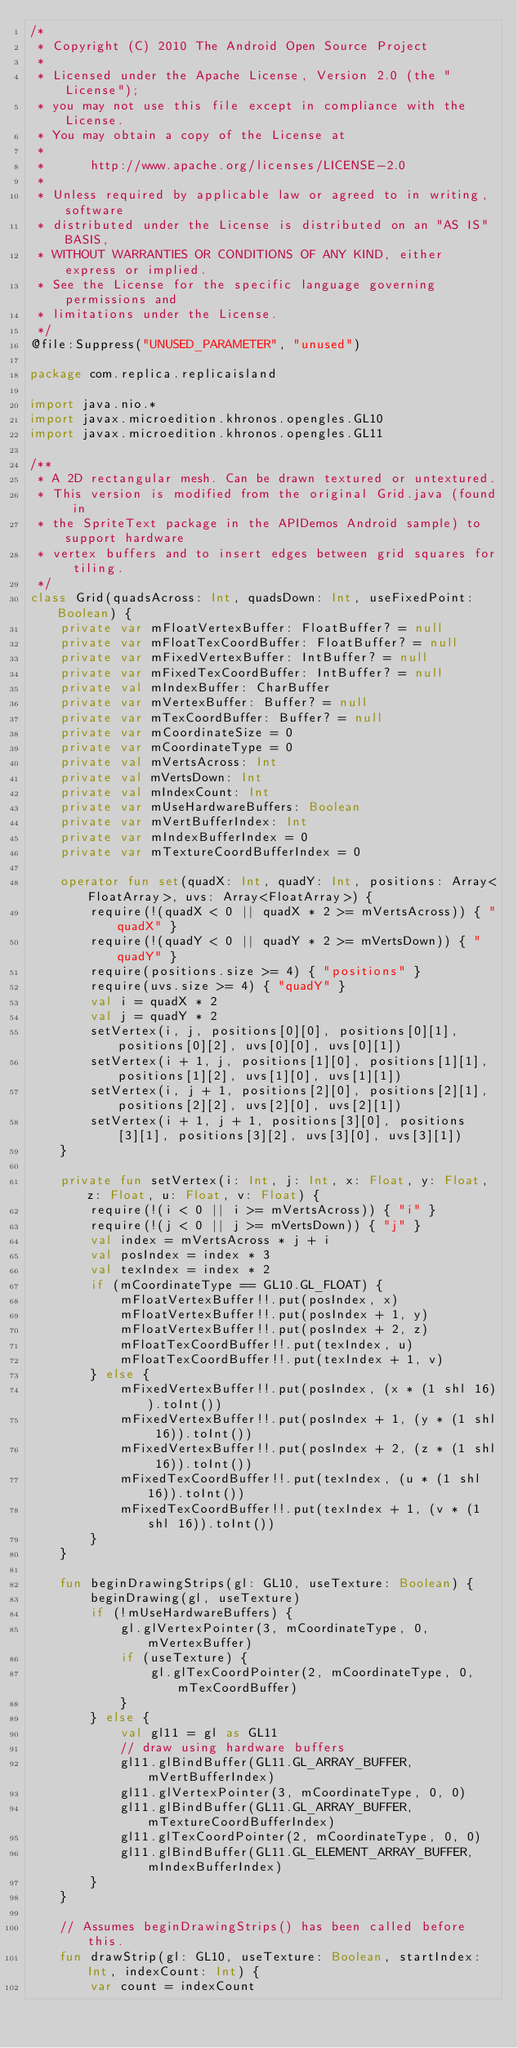<code> <loc_0><loc_0><loc_500><loc_500><_Kotlin_>/*
 * Copyright (C) 2010 The Android Open Source Project
 *
 * Licensed under the Apache License, Version 2.0 (the "License");
 * you may not use this file except in compliance with the License.
 * You may obtain a copy of the License at
 *
 *      http://www.apache.org/licenses/LICENSE-2.0
 *
 * Unless required by applicable law or agreed to in writing, software
 * distributed under the License is distributed on an "AS IS" BASIS,
 * WITHOUT WARRANTIES OR CONDITIONS OF ANY KIND, either express or implied.
 * See the License for the specific language governing permissions and
 * limitations under the License.
 */
@file:Suppress("UNUSED_PARAMETER", "unused")

package com.replica.replicaisland

import java.nio.*
import javax.microedition.khronos.opengles.GL10
import javax.microedition.khronos.opengles.GL11

/**
 * A 2D rectangular mesh. Can be drawn textured or untextured.
 * This version is modified from the original Grid.java (found in
 * the SpriteText package in the APIDemos Android sample) to support hardware
 * vertex buffers and to insert edges between grid squares for tiling.
 */
class Grid(quadsAcross: Int, quadsDown: Int, useFixedPoint: Boolean) {
    private var mFloatVertexBuffer: FloatBuffer? = null
    private var mFloatTexCoordBuffer: FloatBuffer? = null
    private var mFixedVertexBuffer: IntBuffer? = null
    private var mFixedTexCoordBuffer: IntBuffer? = null
    private val mIndexBuffer: CharBuffer
    private var mVertexBuffer: Buffer? = null
    private var mTexCoordBuffer: Buffer? = null
    private var mCoordinateSize = 0
    private var mCoordinateType = 0
    private val mVertsAcross: Int
    private val mVertsDown: Int
    private val mIndexCount: Int
    private var mUseHardwareBuffers: Boolean
    private var mVertBufferIndex: Int
    private var mIndexBufferIndex = 0
    private var mTextureCoordBufferIndex = 0

    operator fun set(quadX: Int, quadY: Int, positions: Array<FloatArray>, uvs: Array<FloatArray>) {
        require(!(quadX < 0 || quadX * 2 >= mVertsAcross)) { "quadX" }
        require(!(quadY < 0 || quadY * 2 >= mVertsDown)) { "quadY" }
        require(positions.size >= 4) { "positions" }
        require(uvs.size >= 4) { "quadY" }
        val i = quadX * 2
        val j = quadY * 2
        setVertex(i, j, positions[0][0], positions[0][1], positions[0][2], uvs[0][0], uvs[0][1])
        setVertex(i + 1, j, positions[1][0], positions[1][1], positions[1][2], uvs[1][0], uvs[1][1])
        setVertex(i, j + 1, positions[2][0], positions[2][1], positions[2][2], uvs[2][0], uvs[2][1])
        setVertex(i + 1, j + 1, positions[3][0], positions[3][1], positions[3][2], uvs[3][0], uvs[3][1])
    }

    private fun setVertex(i: Int, j: Int, x: Float, y: Float, z: Float, u: Float, v: Float) {
        require(!(i < 0 || i >= mVertsAcross)) { "i" }
        require(!(j < 0 || j >= mVertsDown)) { "j" }
        val index = mVertsAcross * j + i
        val posIndex = index * 3
        val texIndex = index * 2
        if (mCoordinateType == GL10.GL_FLOAT) {
            mFloatVertexBuffer!!.put(posIndex, x)
            mFloatVertexBuffer!!.put(posIndex + 1, y)
            mFloatVertexBuffer!!.put(posIndex + 2, z)
            mFloatTexCoordBuffer!!.put(texIndex, u)
            mFloatTexCoordBuffer!!.put(texIndex + 1, v)
        } else {
            mFixedVertexBuffer!!.put(posIndex, (x * (1 shl 16)).toInt())
            mFixedVertexBuffer!!.put(posIndex + 1, (y * (1 shl 16)).toInt())
            mFixedVertexBuffer!!.put(posIndex + 2, (z * (1 shl 16)).toInt())
            mFixedTexCoordBuffer!!.put(texIndex, (u * (1 shl 16)).toInt())
            mFixedTexCoordBuffer!!.put(texIndex + 1, (v * (1 shl 16)).toInt())
        }
    }

    fun beginDrawingStrips(gl: GL10, useTexture: Boolean) {
        beginDrawing(gl, useTexture)
        if (!mUseHardwareBuffers) {
            gl.glVertexPointer(3, mCoordinateType, 0, mVertexBuffer)
            if (useTexture) {
                gl.glTexCoordPointer(2, mCoordinateType, 0, mTexCoordBuffer)
            }
        } else {
            val gl11 = gl as GL11
            // draw using hardware buffers
            gl11.glBindBuffer(GL11.GL_ARRAY_BUFFER, mVertBufferIndex)
            gl11.glVertexPointer(3, mCoordinateType, 0, 0)
            gl11.glBindBuffer(GL11.GL_ARRAY_BUFFER, mTextureCoordBufferIndex)
            gl11.glTexCoordPointer(2, mCoordinateType, 0, 0)
            gl11.glBindBuffer(GL11.GL_ELEMENT_ARRAY_BUFFER, mIndexBufferIndex)
        }
    }

    // Assumes beginDrawingStrips() has been called before this.
    fun drawStrip(gl: GL10, useTexture: Boolean, startIndex: Int, indexCount: Int) {
        var count = indexCount</code> 